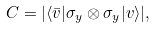Convert formula to latex. <formula><loc_0><loc_0><loc_500><loc_500>C = | \langle \bar { v } | \sigma _ { y } \otimes \sigma _ { y } | v \rangle | ,</formula> 